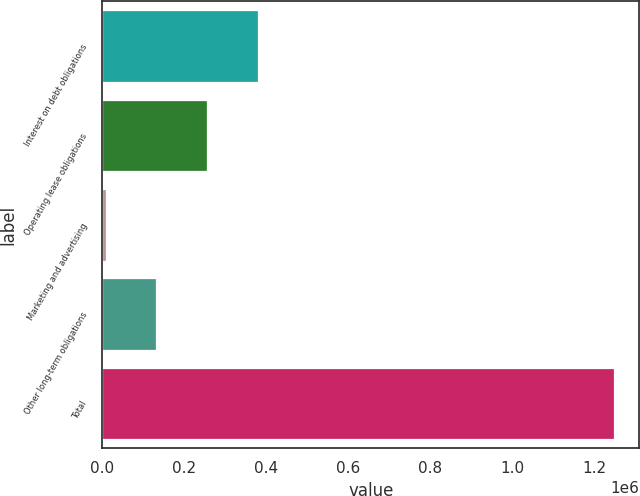<chart> <loc_0><loc_0><loc_500><loc_500><bar_chart><fcel>Interest on debt obligations<fcel>Operating lease obligations<fcel>Marketing and advertising<fcel>Other long-term obligations<fcel>Total<nl><fcel>380335<fcel>256295<fcel>8213<fcel>132254<fcel>1.24862e+06<nl></chart> 